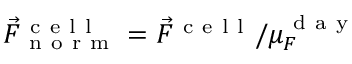<formula> <loc_0><loc_0><loc_500><loc_500>\vec { F } _ { n o r m } ^ { c e l l } = \vec { F } ^ { c e l l } / \mu _ { F } ^ { d a y }</formula> 